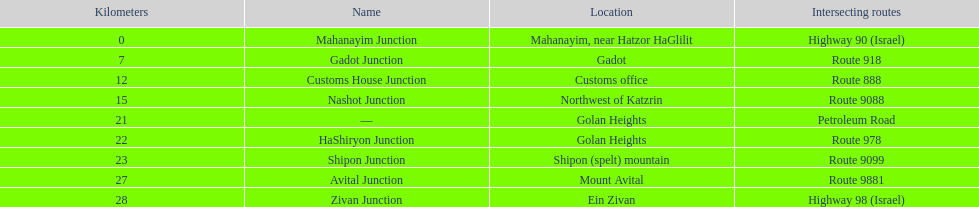At which junction is the maximum distance from mahanayim junction? Zivan Junction. 